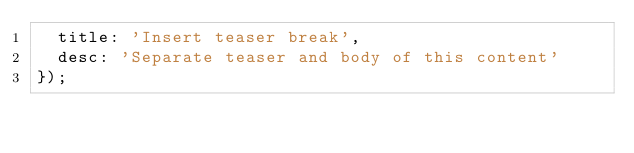<code> <loc_0><loc_0><loc_500><loc_500><_JavaScript_>  title: 'Insert teaser break',
  desc: 'Separate teaser and body of this content'
});

</code> 